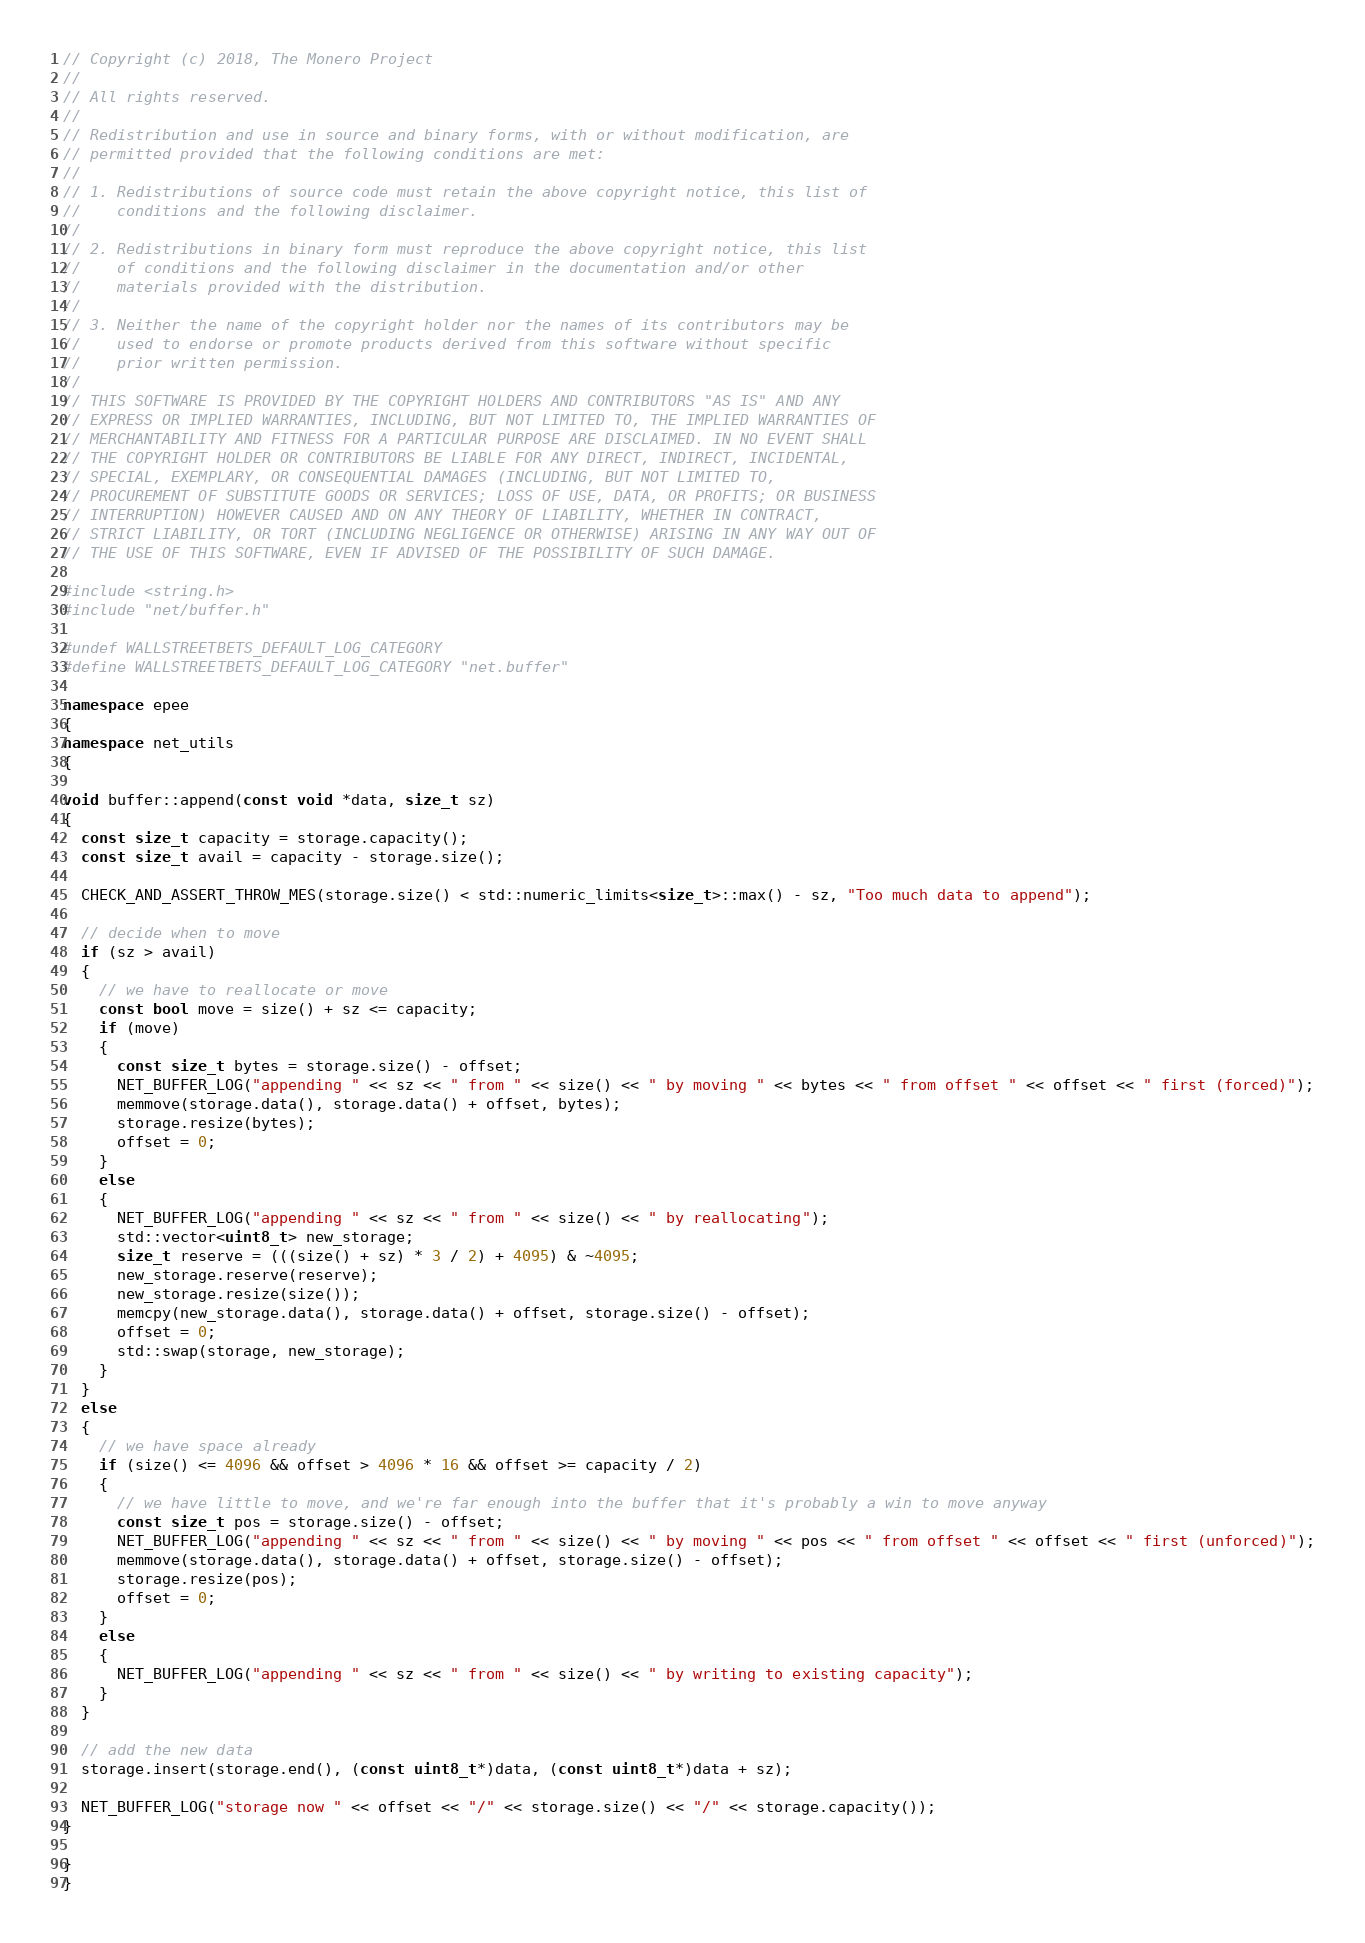Convert code to text. <code><loc_0><loc_0><loc_500><loc_500><_C++_>// Copyright (c) 2018, The Monero Project
//
// All rights reserved.
//
// Redistribution and use in source and binary forms, with or without modification, are
// permitted provided that the following conditions are met:
//
// 1. Redistributions of source code must retain the above copyright notice, this list of
//    conditions and the following disclaimer.
//
// 2. Redistributions in binary form must reproduce the above copyright notice, this list
//    of conditions and the following disclaimer in the documentation and/or other
//    materials provided with the distribution.
//
// 3. Neither the name of the copyright holder nor the names of its contributors may be
//    used to endorse or promote products derived from this software without specific
//    prior written permission.
//
// THIS SOFTWARE IS PROVIDED BY THE COPYRIGHT HOLDERS AND CONTRIBUTORS "AS IS" AND ANY
// EXPRESS OR IMPLIED WARRANTIES, INCLUDING, BUT NOT LIMITED TO, THE IMPLIED WARRANTIES OF
// MERCHANTABILITY AND FITNESS FOR A PARTICULAR PURPOSE ARE DISCLAIMED. IN NO EVENT SHALL
// THE COPYRIGHT HOLDER OR CONTRIBUTORS BE LIABLE FOR ANY DIRECT, INDIRECT, INCIDENTAL,
// SPECIAL, EXEMPLARY, OR CONSEQUENTIAL DAMAGES (INCLUDING, BUT NOT LIMITED TO,
// PROCUREMENT OF SUBSTITUTE GOODS OR SERVICES; LOSS OF USE, DATA, OR PROFITS; OR BUSINESS
// INTERRUPTION) HOWEVER CAUSED AND ON ANY THEORY OF LIABILITY, WHETHER IN CONTRACT,
// STRICT LIABILITY, OR TORT (INCLUDING NEGLIGENCE OR OTHERWISE) ARISING IN ANY WAY OUT OF
// THE USE OF THIS SOFTWARE, EVEN IF ADVISED OF THE POSSIBILITY OF SUCH DAMAGE.

#include <string.h>
#include "net/buffer.h"

#undef WALLSTREETBETS_DEFAULT_LOG_CATEGORY
#define WALLSTREETBETS_DEFAULT_LOG_CATEGORY "net.buffer"

namespace epee
{
namespace net_utils
{

void buffer::append(const void *data, size_t sz)
{
  const size_t capacity = storage.capacity();
  const size_t avail = capacity - storage.size();

  CHECK_AND_ASSERT_THROW_MES(storage.size() < std::numeric_limits<size_t>::max() - sz, "Too much data to append");

  // decide when to move
  if (sz > avail)
  {
    // we have to reallocate or move
    const bool move = size() + sz <= capacity;
    if (move)
    {
      const size_t bytes = storage.size() - offset;
      NET_BUFFER_LOG("appending " << sz << " from " << size() << " by moving " << bytes << " from offset " << offset << " first (forced)");
      memmove(storage.data(), storage.data() + offset, bytes);
      storage.resize(bytes);
      offset = 0;
    }
    else
    {
      NET_BUFFER_LOG("appending " << sz << " from " << size() << " by reallocating");
      std::vector<uint8_t> new_storage;
      size_t reserve = (((size() + sz) * 3 / 2) + 4095) & ~4095;
      new_storage.reserve(reserve);
      new_storage.resize(size());
      memcpy(new_storage.data(), storage.data() + offset, storage.size() - offset);
      offset = 0;
      std::swap(storage, new_storage);
    }
  }
  else
  {
    // we have space already
    if (size() <= 4096 && offset > 4096 * 16 && offset >= capacity / 2)
    {
      // we have little to move, and we're far enough into the buffer that it's probably a win to move anyway
      const size_t pos = storage.size() - offset;
      NET_BUFFER_LOG("appending " << sz << " from " << size() << " by moving " << pos << " from offset " << offset << " first (unforced)");
      memmove(storage.data(), storage.data() + offset, storage.size() - offset);
      storage.resize(pos);
      offset = 0;
    }
    else
    {
      NET_BUFFER_LOG("appending " << sz << " from " << size() << " by writing to existing capacity");
    }
  }

  // add the new data
  storage.insert(storage.end(), (const uint8_t*)data, (const uint8_t*)data + sz);

  NET_BUFFER_LOG("storage now " << offset << "/" << storage.size() << "/" << storage.capacity());
}

}
}
</code> 